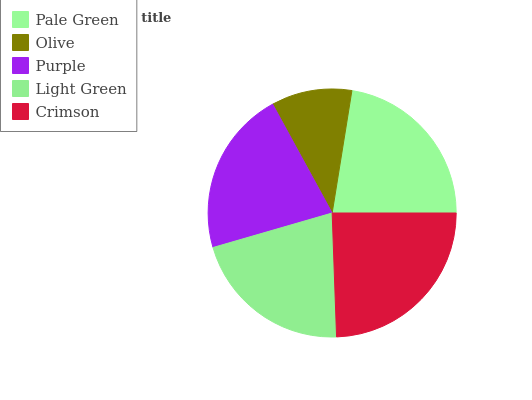Is Olive the minimum?
Answer yes or no. Yes. Is Crimson the maximum?
Answer yes or no. Yes. Is Purple the minimum?
Answer yes or no. No. Is Purple the maximum?
Answer yes or no. No. Is Purple greater than Olive?
Answer yes or no. Yes. Is Olive less than Purple?
Answer yes or no. Yes. Is Olive greater than Purple?
Answer yes or no. No. Is Purple less than Olive?
Answer yes or no. No. Is Purple the high median?
Answer yes or no. Yes. Is Purple the low median?
Answer yes or no. Yes. Is Pale Green the high median?
Answer yes or no. No. Is Light Green the low median?
Answer yes or no. No. 